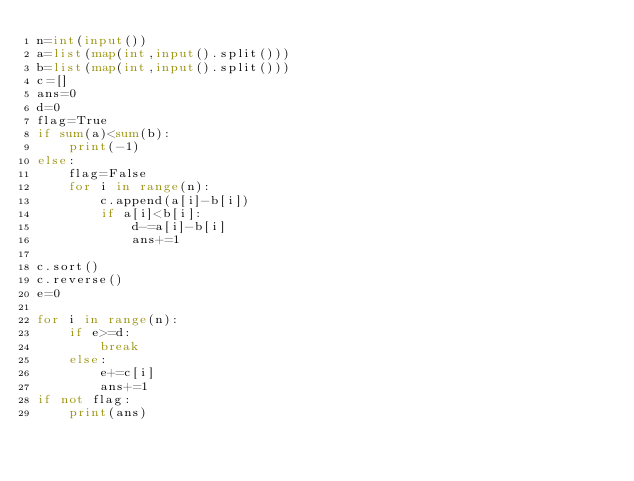Convert code to text. <code><loc_0><loc_0><loc_500><loc_500><_Python_>n=int(input())
a=list(map(int,input().split()))
b=list(map(int,input().split()))
c=[]
ans=0
d=0
flag=True
if sum(a)<sum(b):
    print(-1)
else:
    flag=False
    for i in range(n):
        c.append(a[i]-b[i])
        if a[i]<b[i]:
            d-=a[i]-b[i]
            ans+=1
            
c.sort()
c.reverse()
e=0

for i in range(n):
    if e>=d:
        break
    else:
        e+=c[i]
        ans+=1
if not flag:
    print(ans)
</code> 